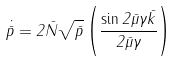<formula> <loc_0><loc_0><loc_500><loc_500>\dot { \bar { p } } = 2 \bar { N } \sqrt { \bar { p } } \left ( \frac { \sin 2 \bar { \mu } \gamma \bar { k } } { 2 \bar { \mu } \gamma } \right )</formula> 